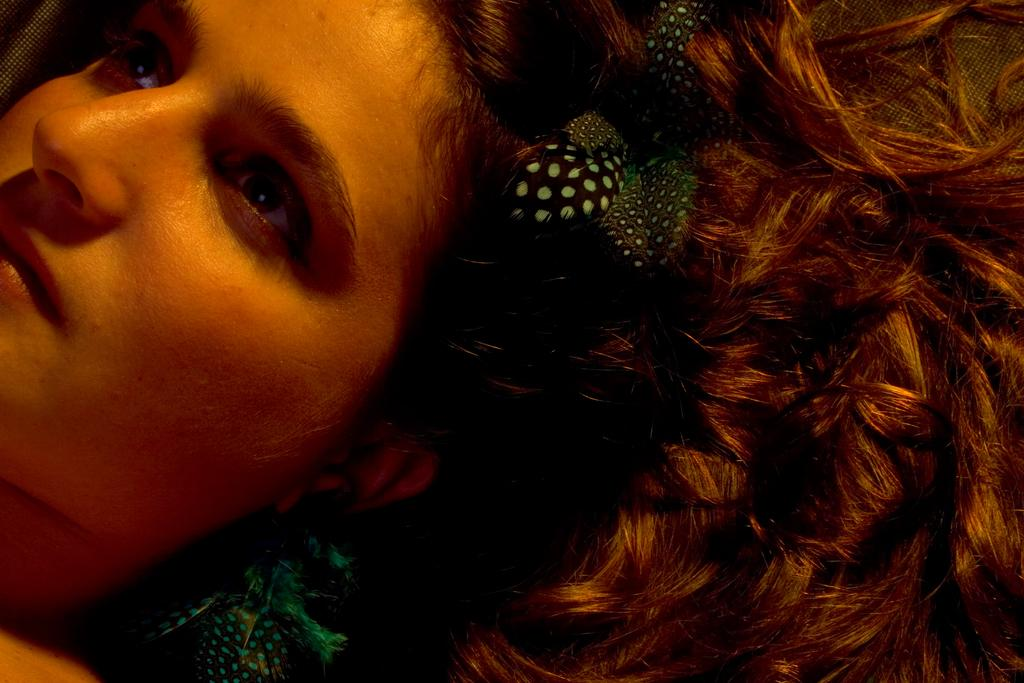What is the main subject of the image? The main subject of the image is a person's face. Can you describe any additional details about the person's face? Yes, there are objects on the person's hair in the image. What verse is being recited by the person in the image? There is no indication in the image that the person is reciting a verse, so it cannot be determined from the picture. 